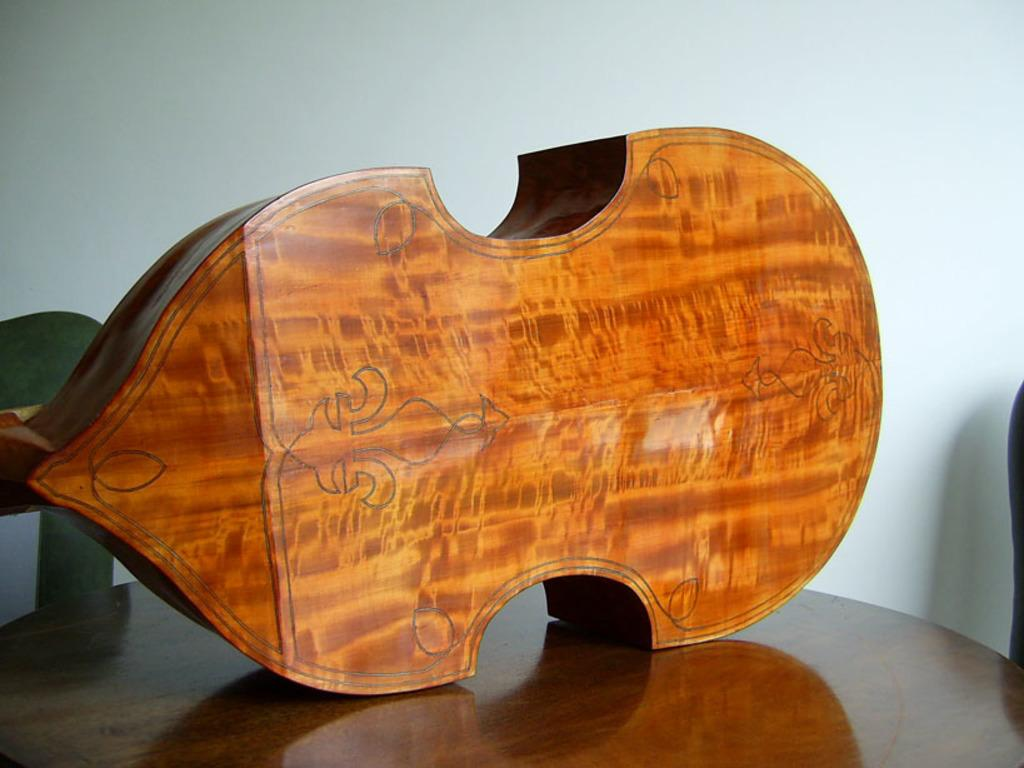What type of object is on the table in the image? There is a wooden object on the table in the image. Can you describe the object on the right side of the image? Unfortunately, the provided facts do not specify the object on the right side of the image. What can be seen in the background of the image? There is a wall in the background of the image. Is there a fight happening between the wooden object and the wall in the image? No, there is no fight happening between the wooden object and the wall in the image. There is no indication of any conflict or interaction between these objects. 